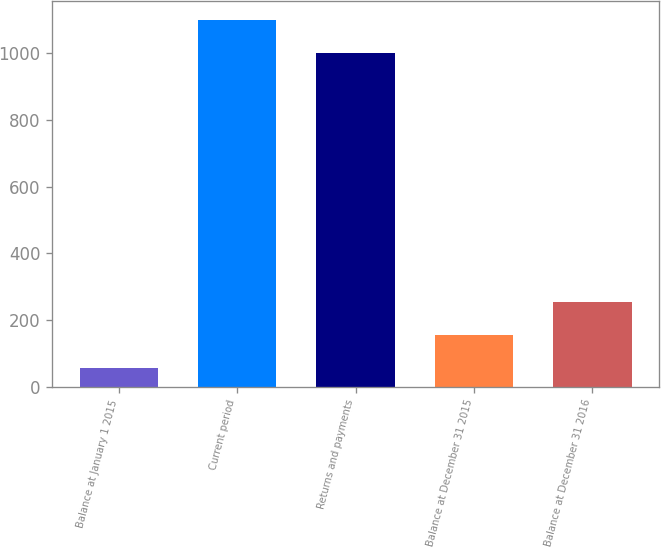Convert chart to OTSL. <chart><loc_0><loc_0><loc_500><loc_500><bar_chart><fcel>Balance at January 1 2015<fcel>Current period<fcel>Returns and payments<fcel>Balance at December 31 2015<fcel>Balance at December 31 2016<nl><fcel>56<fcel>1100.7<fcel>1002<fcel>154.7<fcel>253.4<nl></chart> 